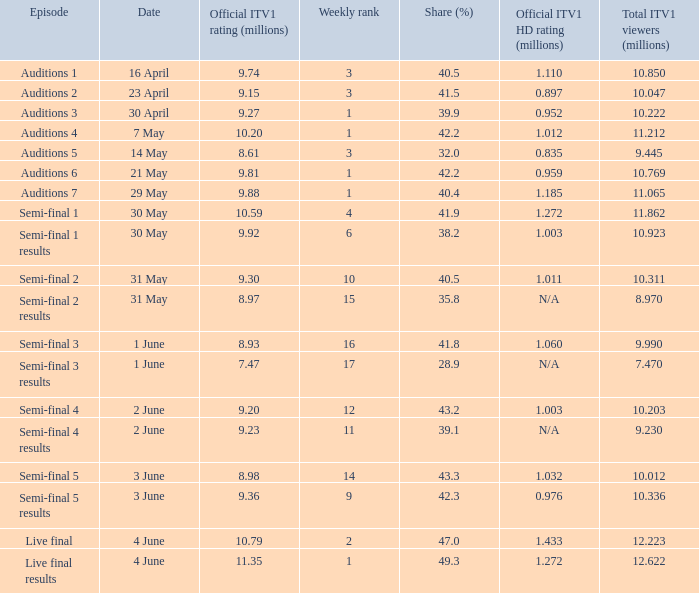Which episode had an official itv1 hd viewership of Auditions 7. 